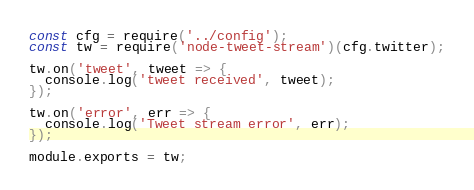<code> <loc_0><loc_0><loc_500><loc_500><_JavaScript_>const cfg = require('../config');
const tw = require('node-tweet-stream')(cfg.twitter);

tw.on('tweet', tweet => {
  console.log('tweet received', tweet);
});

tw.on('error', err => {
  console.log('Tweet stream error', err);
});

module.exports = tw;
</code> 